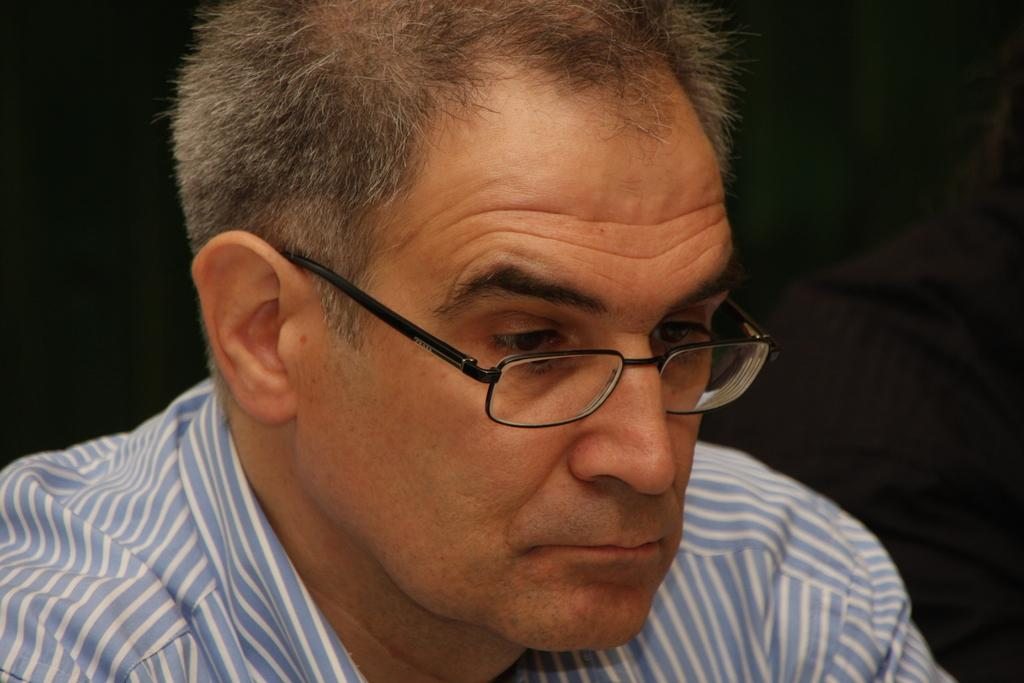What is the main subject of the image? The main subject of the image is a man. Can you describe the man's clothing in the image? The man is wearing a striped shirt in the image. What accessory is the man wearing in the image? The man is wearing spectacles in the image. What type of appliance is the man using to wave at the edge of the image? There is no appliance or waving action present in the image; it only features a man wearing a striped shirt and spectacles. 